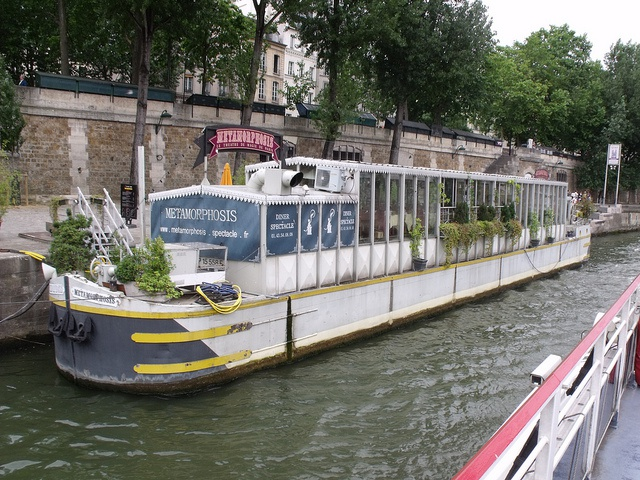Describe the objects in this image and their specific colors. I can see boat in black, lightgray, gray, and darkgray tones, boat in black, lavender, darkgray, lightpink, and gray tones, potted plant in black, darkgreen, and gray tones, potted plant in black, gray, darkgray, and darkgreen tones, and potted plant in black, darkgreen, olive, gray, and darkgray tones in this image. 